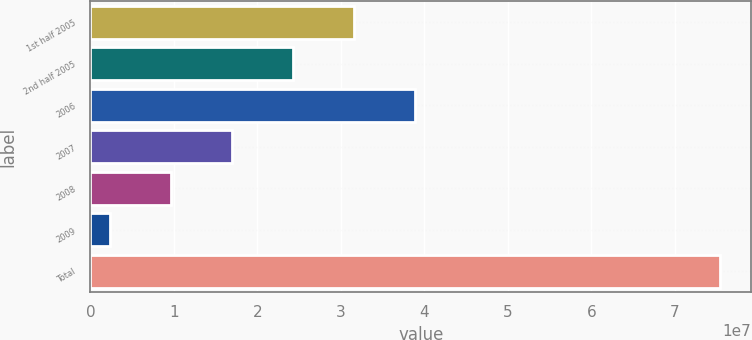Convert chart to OTSL. <chart><loc_0><loc_0><loc_500><loc_500><bar_chart><fcel>1st half 2005<fcel>2nd half 2005<fcel>2006<fcel>2007<fcel>2008<fcel>2009<fcel>Total<nl><fcel>3.15586e+07<fcel>2.42492e+07<fcel>3.8868e+07<fcel>1.69398e+07<fcel>9.6304e+06<fcel>2.321e+06<fcel>7.5415e+07<nl></chart> 